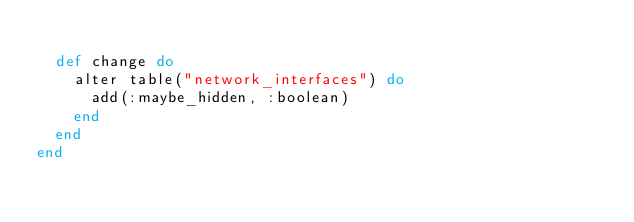Convert code to text. <code><loc_0><loc_0><loc_500><loc_500><_Elixir_>
  def change do
    alter table("network_interfaces") do
      add(:maybe_hidden, :boolean)
    end
  end
end
</code> 